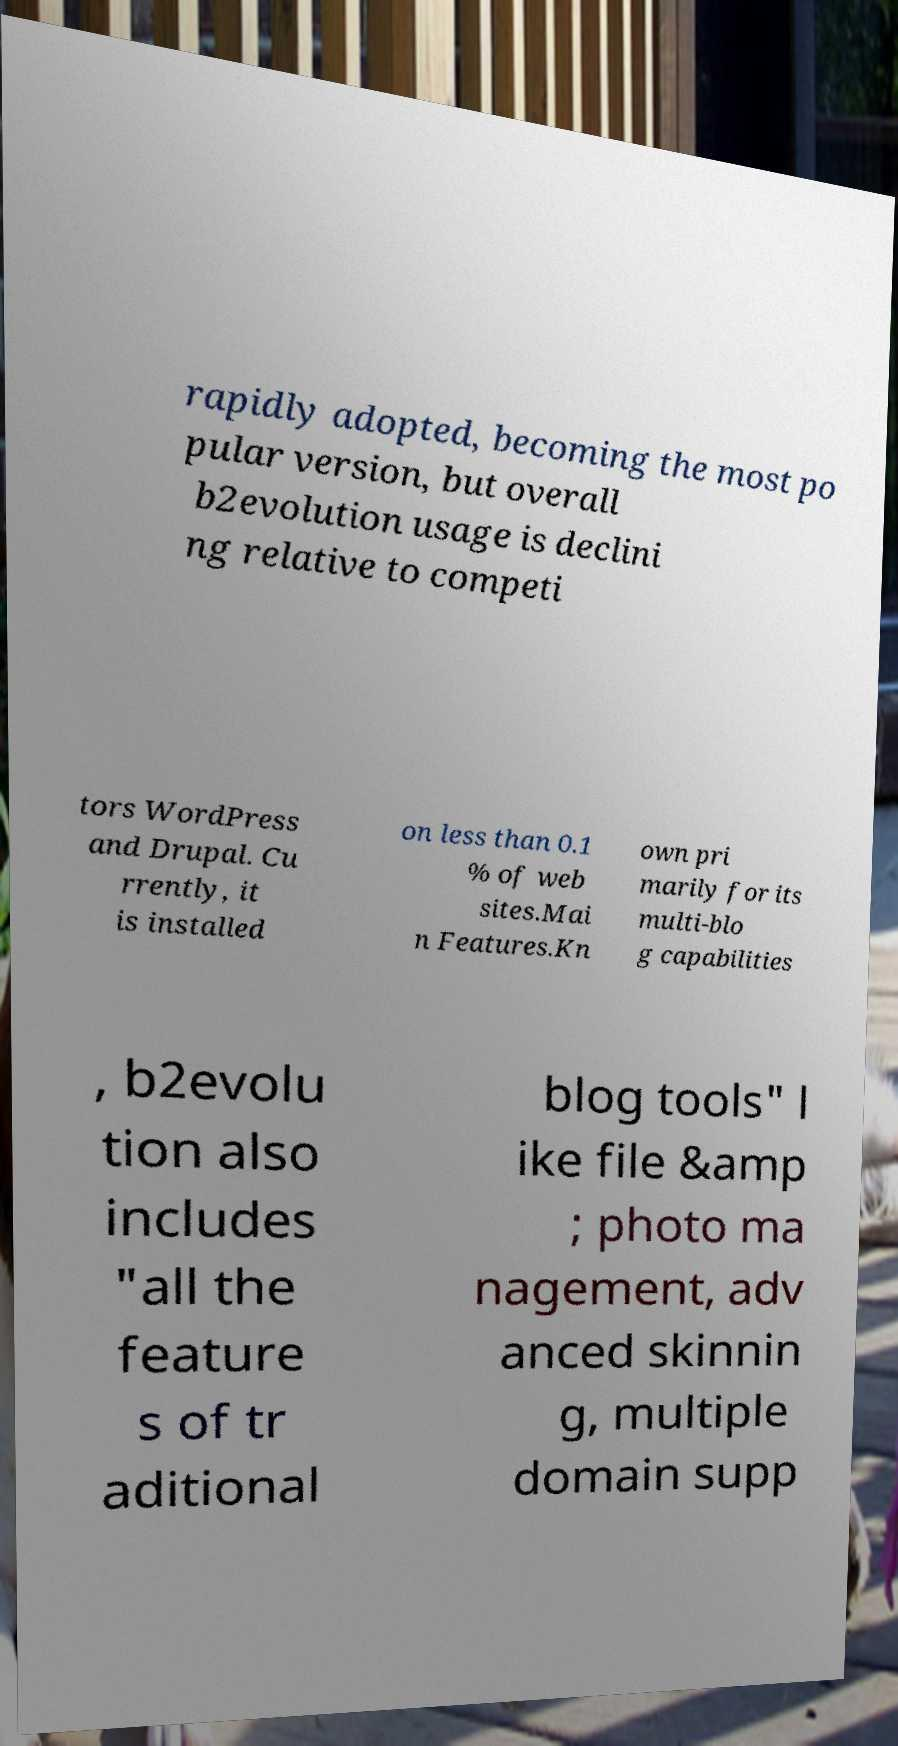Please read and relay the text visible in this image. What does it say? rapidly adopted, becoming the most po pular version, but overall b2evolution usage is declini ng relative to competi tors WordPress and Drupal. Cu rrently, it is installed on less than 0.1 % of web sites.Mai n Features.Kn own pri marily for its multi-blo g capabilities , b2evolu tion also includes "all the feature s of tr aditional blog tools" l ike file &amp ; photo ma nagement, adv anced skinnin g, multiple domain supp 